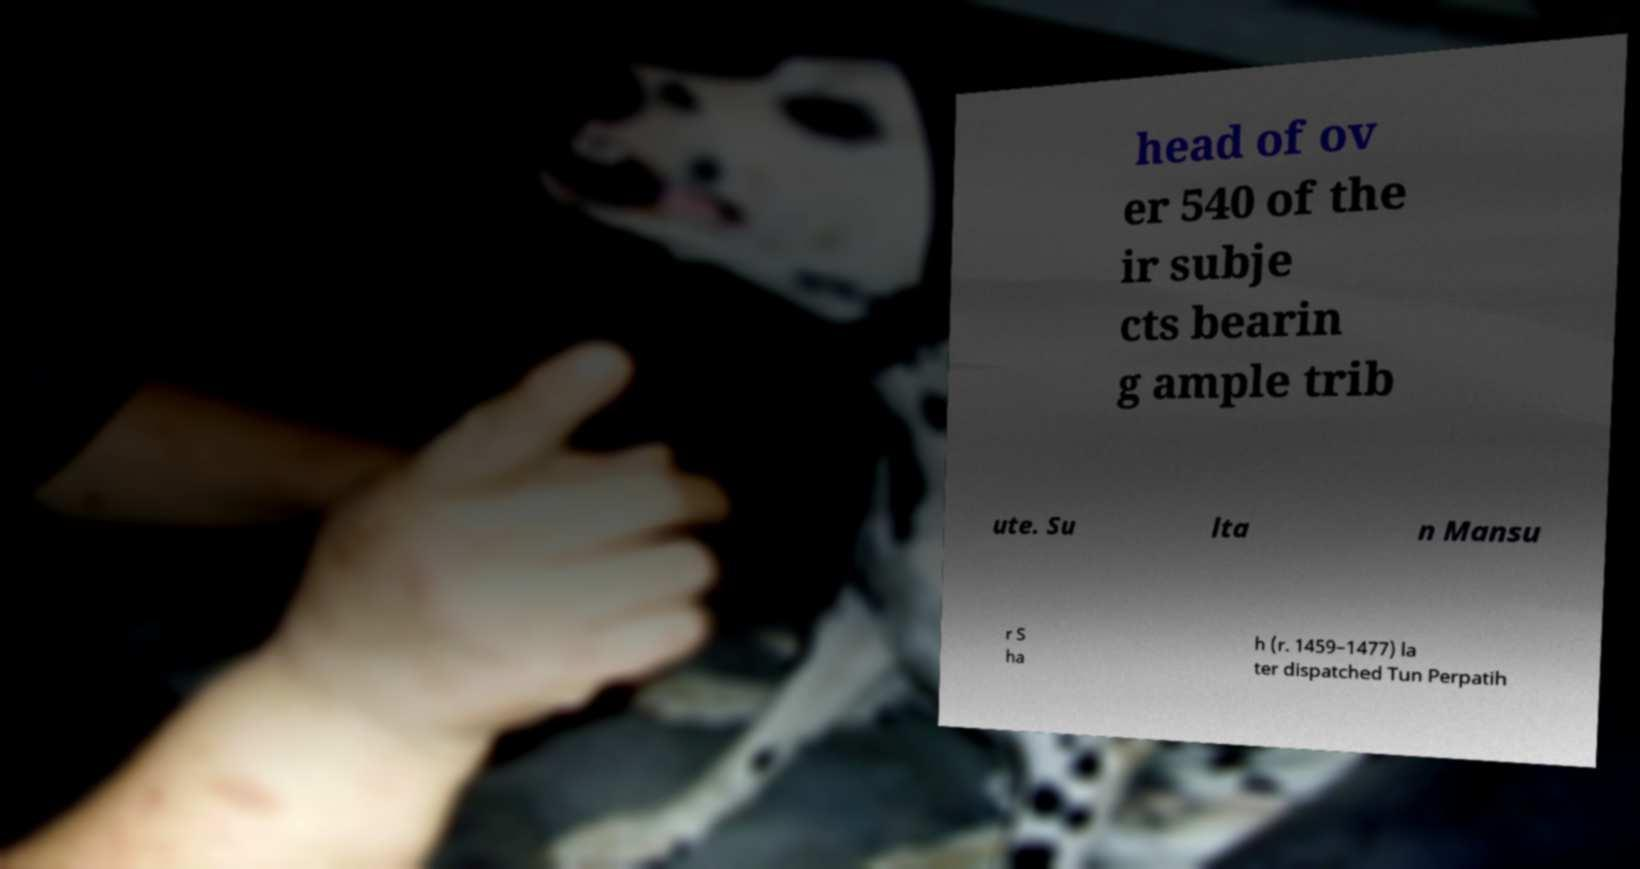I need the written content from this picture converted into text. Can you do that? head of ov er 540 of the ir subje cts bearin g ample trib ute. Su lta n Mansu r S ha h (r. 1459–1477) la ter dispatched Tun Perpatih 